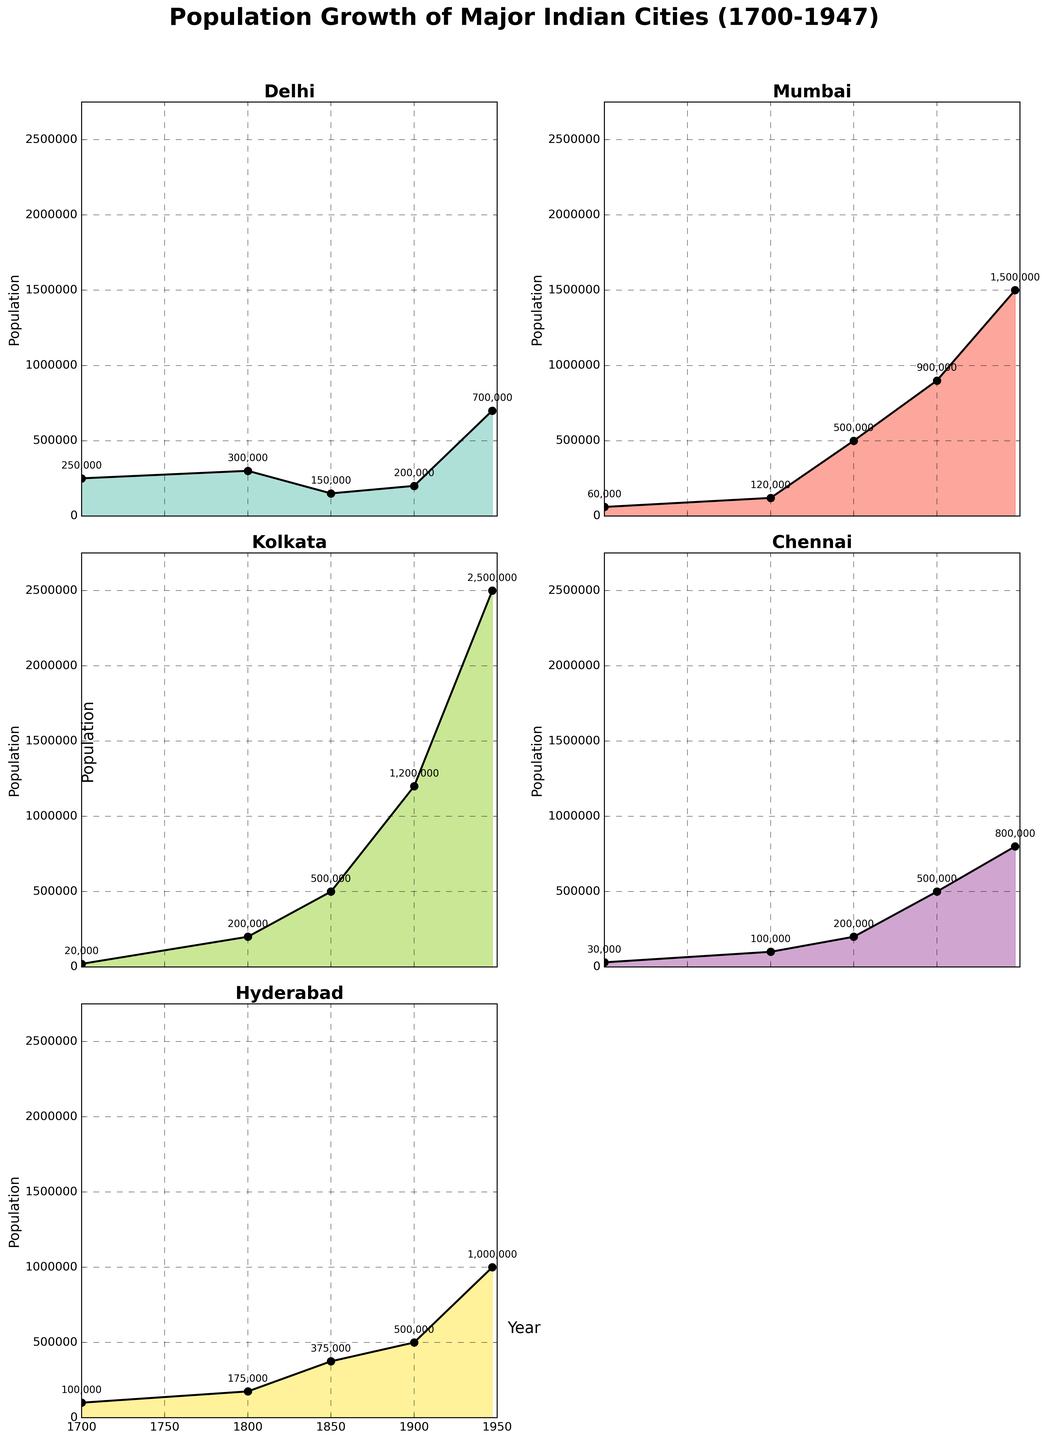How many cities are displayed in the entire figure? The figure displays subplots for major cities in India. By checking the individual titles of each subplot, we can count the total number of cities.
Answer: 5 Which city had the highest population in 1947? By examining the endings of the subplots where the x-axis meets 1947, we see that Kolkata has the highest ending population value.
Answer: Kolkata What is the total combined population of all cities in 1700? Summing up the population values from 1700 for each city: Delhi (250,000), Mumbai (60,000), Kolkata (20,000), Chennai (30,000), Hyderabad (100,000), totals to 250,000 + 60,000 + 20,000 + 30,000 + 100,000 = 460,000.
Answer: 460,000 Which city experienced the most significant population growth between 1800 and 1947? To find this, we subtract the population in 1800 from the population in 1947 for each city: Delhi (400,000), Mumbai (1,380,000), Kolkata (2,300,000), Chennai (700,000), Hyderabad (825,000). The largest growth is for Kolkata.
Answer: Kolkata In which year did Hyderabad reach a population of approximately 0.5 million? By examining the population line chart for Hyderabad, it shows that it crosses 500,000 in the year 1900.
Answer: 1900 Which city experienced a population decline in the 19th century? By observing the population trends across each subplot, Delhi shows a decline from 300,000 in 1800 to 150,000 in 1850.
Answer: Delhi What is the average population of Chennai throughout the years displayed? Add up the populations for Chennai (30,000 in 1700, 100,000 in 1800, 200,000 in 1850, 500,000 in 1900, 800,000 in 1947) and divide by the number of data points: (30,000 + 100,000 + 200,000 + 500,000 + 800,000) / 5 = 1,630,000 / 5 = 326,000.
Answer: 326,000 Between 1700 and 1800, which city had the highest percentage increase in population? Calculate the percentage increase for each city between 1700 and 1800:  [(New Population - Old Population) / Old Population] × 100. For Delhi: [(300,000 - 250,000)/250,000]*100 = 20%. For Mumbai: [(120,000 - 60,000)/60,000]*100 = 100%. For Kolkata: [(200,000 - 20,000)/20,000]*100 = 900%. For Chennai: [(100,000 - 30,000)/30,000]*100 = 233.33%. For Hyderabad: [(175,000 - 100,000)/100,000]*100 = 75%. Hence, Kolkata had the highest percentage increase.
Answer: Kolkata Which two cities had a population crossing over one million first? By looking at the respective years in the area charts, we can see that Kolkata crossed one million by 1900, followed by Mumbai by 1947.
Answer: Kolkata and Mumbai 